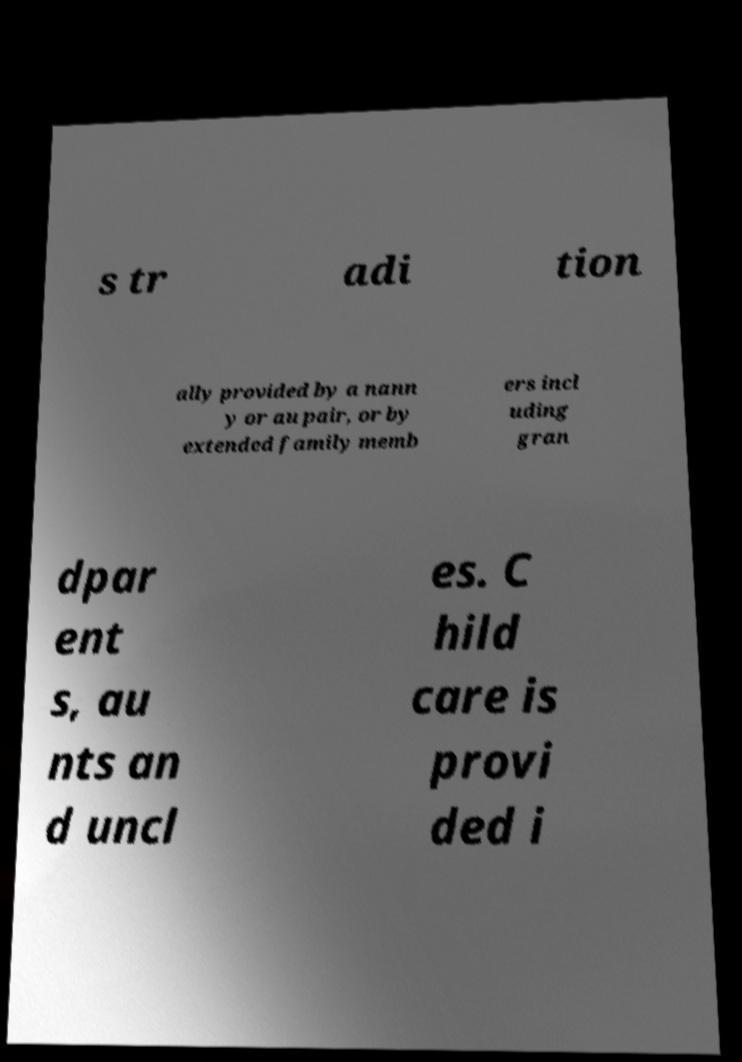Please read and relay the text visible in this image. What does it say? s tr adi tion ally provided by a nann y or au pair, or by extended family memb ers incl uding gran dpar ent s, au nts an d uncl es. C hild care is provi ded i 